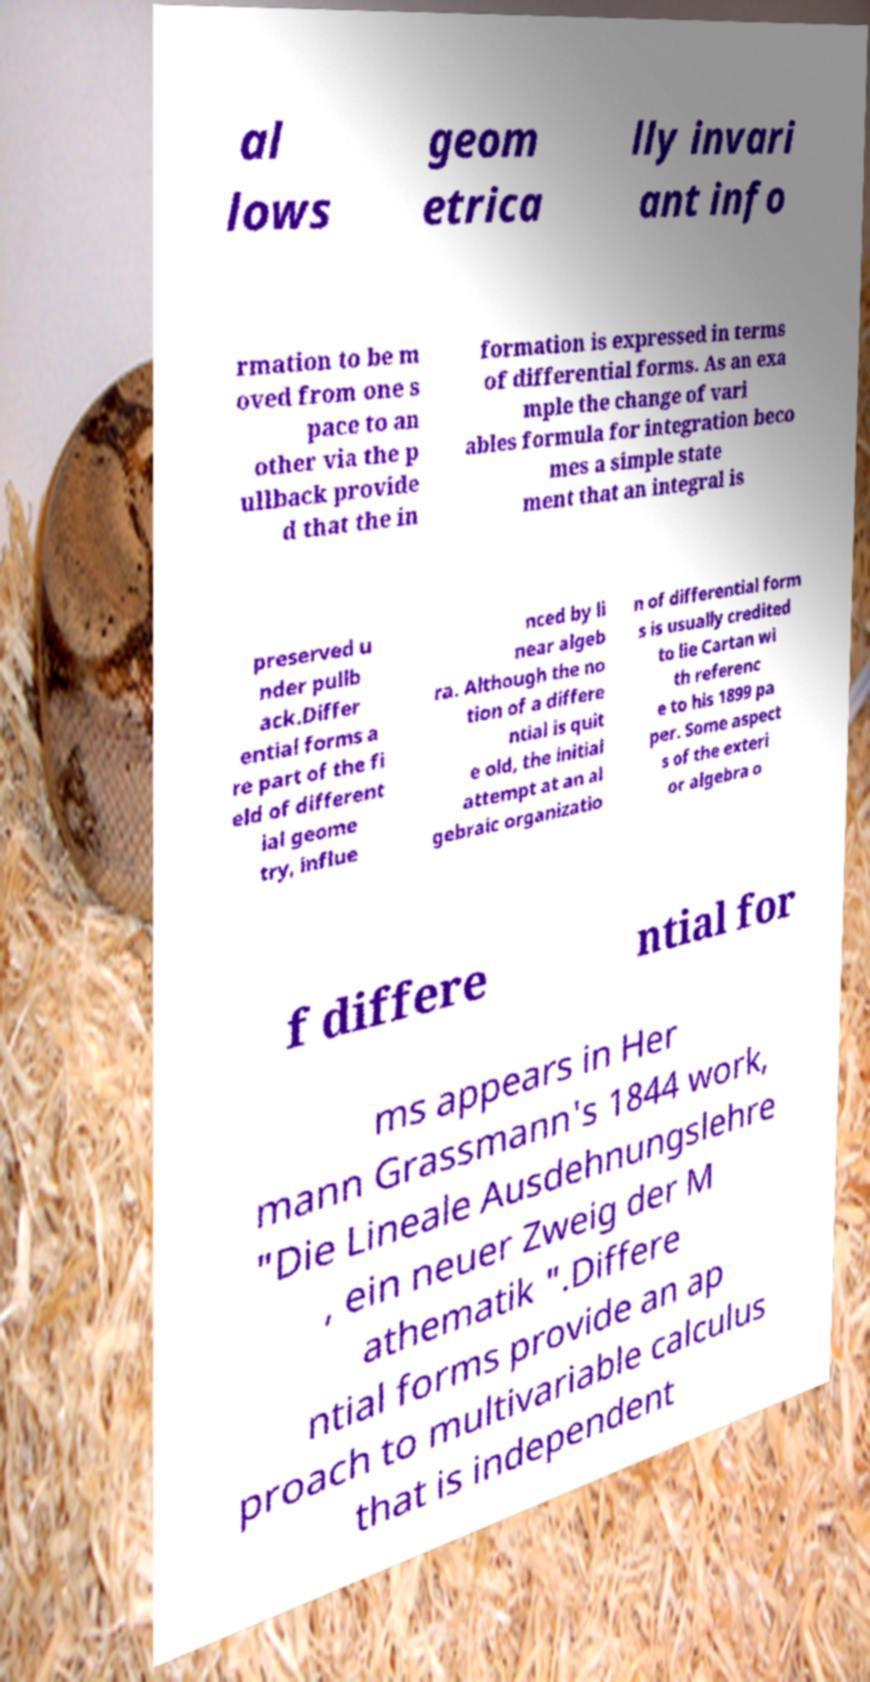I need the written content from this picture converted into text. Can you do that? al lows geom etrica lly invari ant info rmation to be m oved from one s pace to an other via the p ullback provide d that the in formation is expressed in terms of differential forms. As an exa mple the change of vari ables formula for integration beco mes a simple state ment that an integral is preserved u nder pullb ack.Differ ential forms a re part of the fi eld of different ial geome try, influe nced by li near algeb ra. Although the no tion of a differe ntial is quit e old, the initial attempt at an al gebraic organizatio n of differential form s is usually credited to lie Cartan wi th referenc e to his 1899 pa per. Some aspect s of the exteri or algebra o f differe ntial for ms appears in Her mann Grassmann's 1844 work, "Die Lineale Ausdehnungslehre , ein neuer Zweig der M athematik ".Differe ntial forms provide an ap proach to multivariable calculus that is independent 